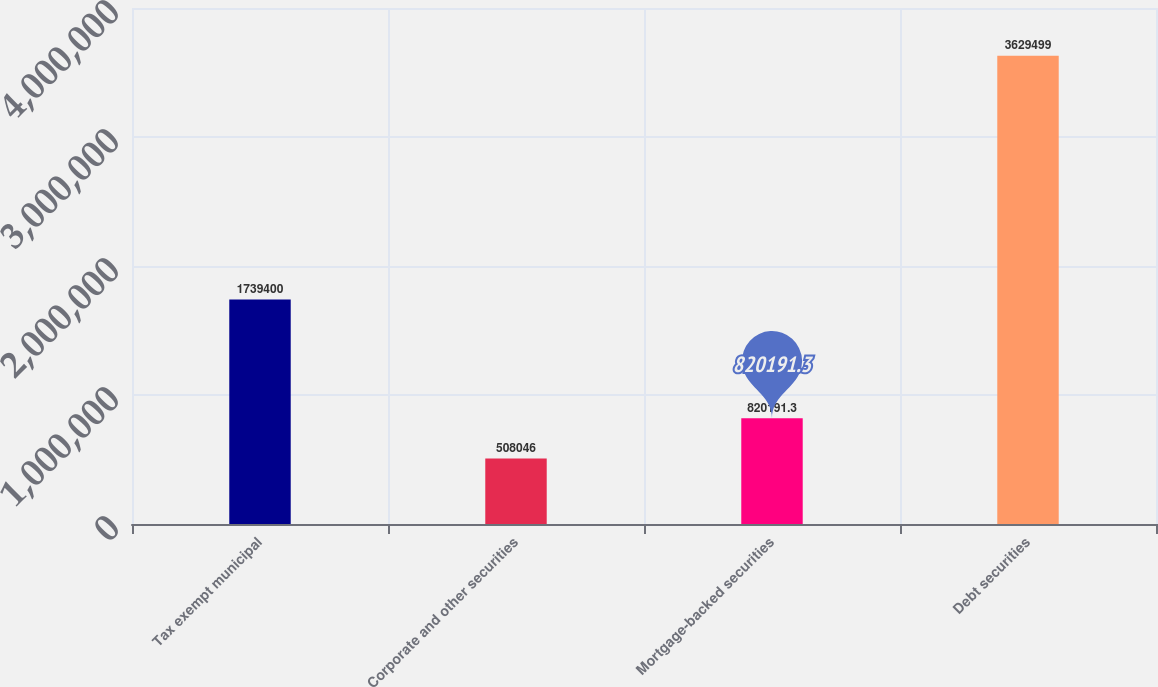<chart> <loc_0><loc_0><loc_500><loc_500><bar_chart><fcel>Tax exempt municipal<fcel>Corporate and other securities<fcel>Mortgage-backed securities<fcel>Debt securities<nl><fcel>1.7394e+06<fcel>508046<fcel>820191<fcel>3.6295e+06<nl></chart> 